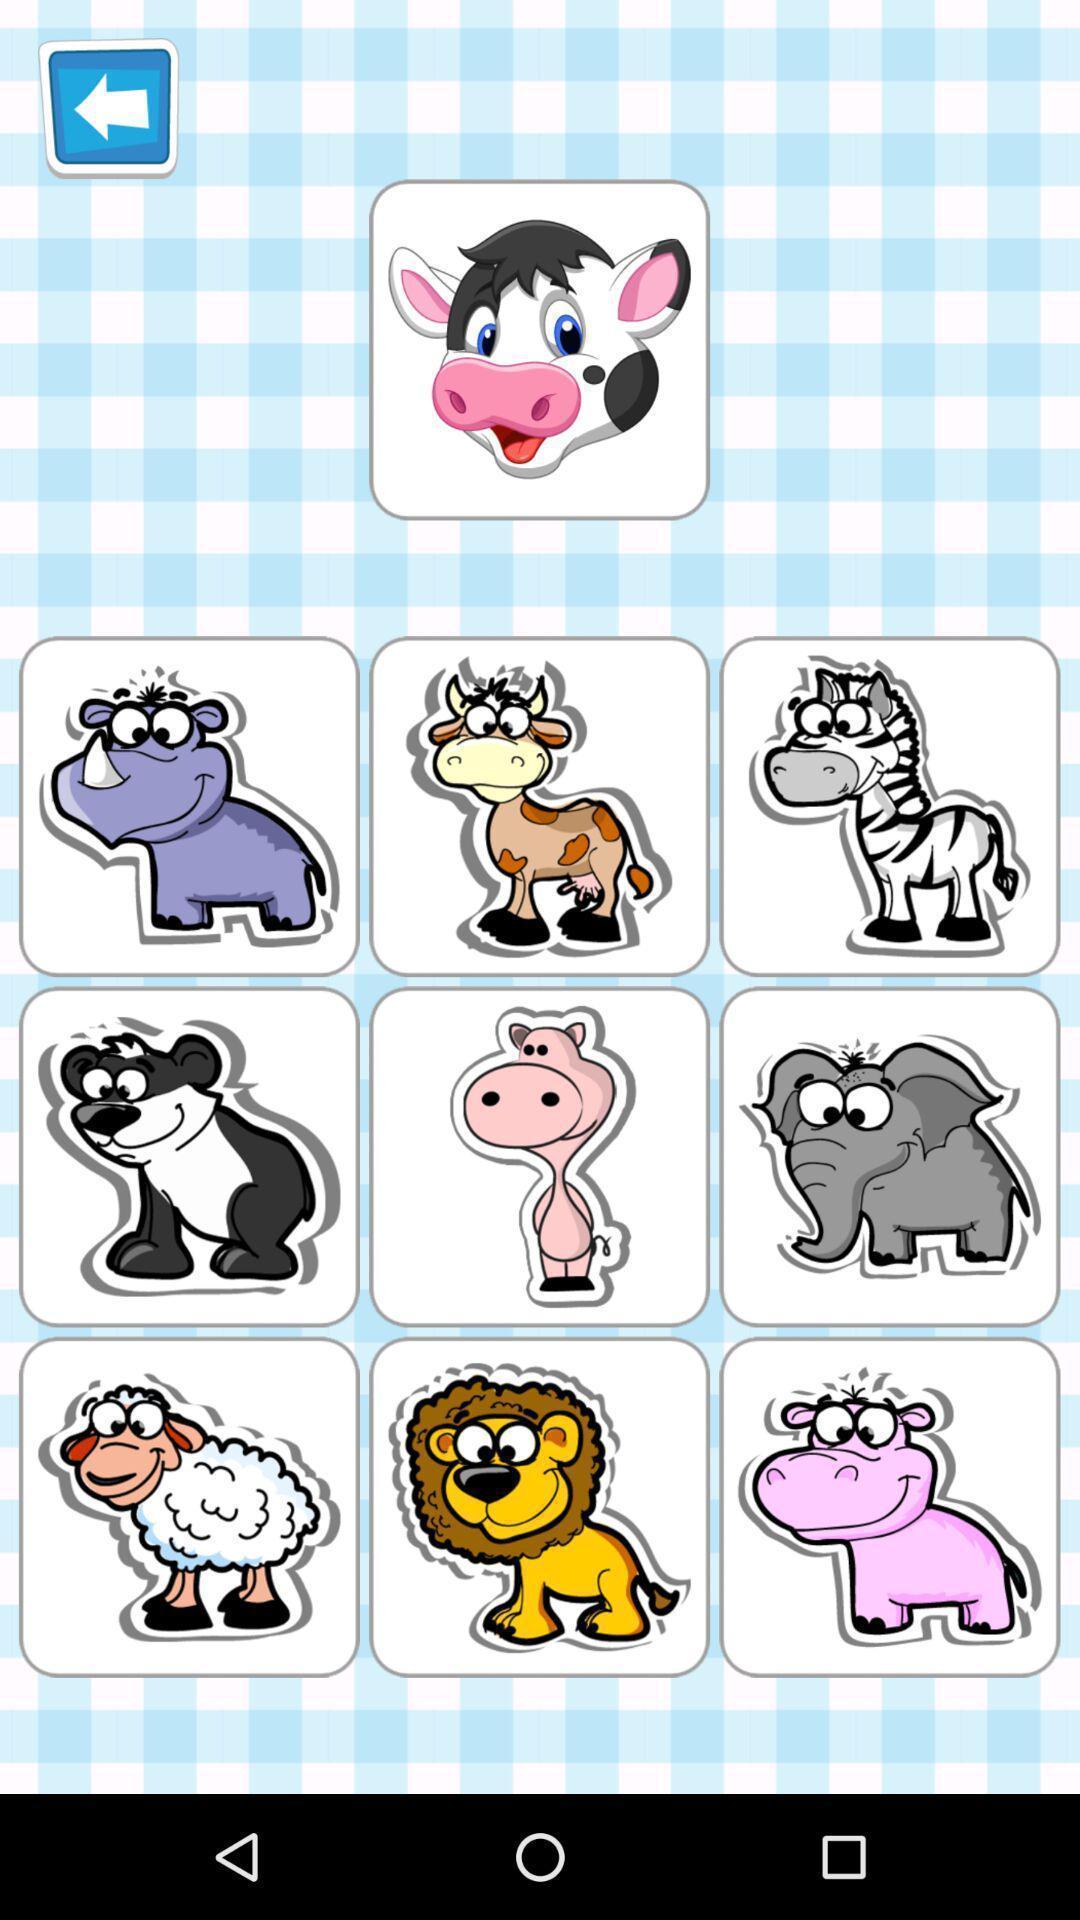Provide a detailed account of this screenshot. Various animal logos displayed of a gaming app. 